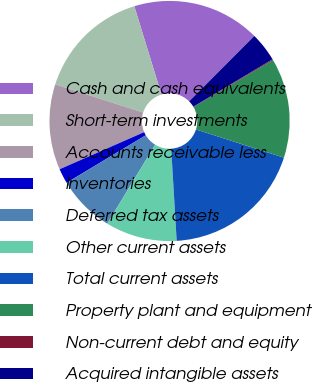<chart> <loc_0><loc_0><loc_500><loc_500><pie_chart><fcel>Cash and cash equivalents<fcel>Short-term investments<fcel>Accounts receivable less<fcel>Inventories<fcel>Deferred tax assets<fcel>Other current assets<fcel>Total current assets<fcel>Property plant and equipment<fcel>Non-current debt and equity<fcel>Acquired intangible assets<nl><fcel>17.22%<fcel>15.32%<fcel>11.52%<fcel>2.02%<fcel>7.72%<fcel>9.62%<fcel>19.12%<fcel>13.42%<fcel>0.12%<fcel>3.92%<nl></chart> 